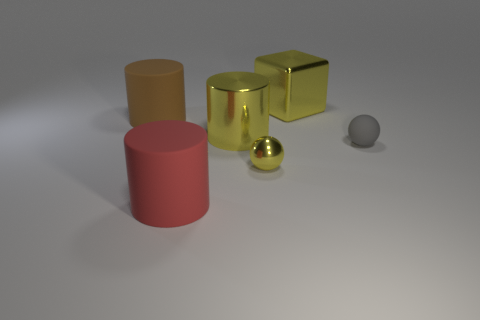Add 2 small yellow cylinders. How many objects exist? 8 Subtract all blocks. How many objects are left? 5 Subtract all small matte balls. Subtract all red cylinders. How many objects are left? 4 Add 6 big blocks. How many big blocks are left? 7 Add 2 tiny metallic things. How many tiny metallic things exist? 3 Subtract 0 blue cylinders. How many objects are left? 6 